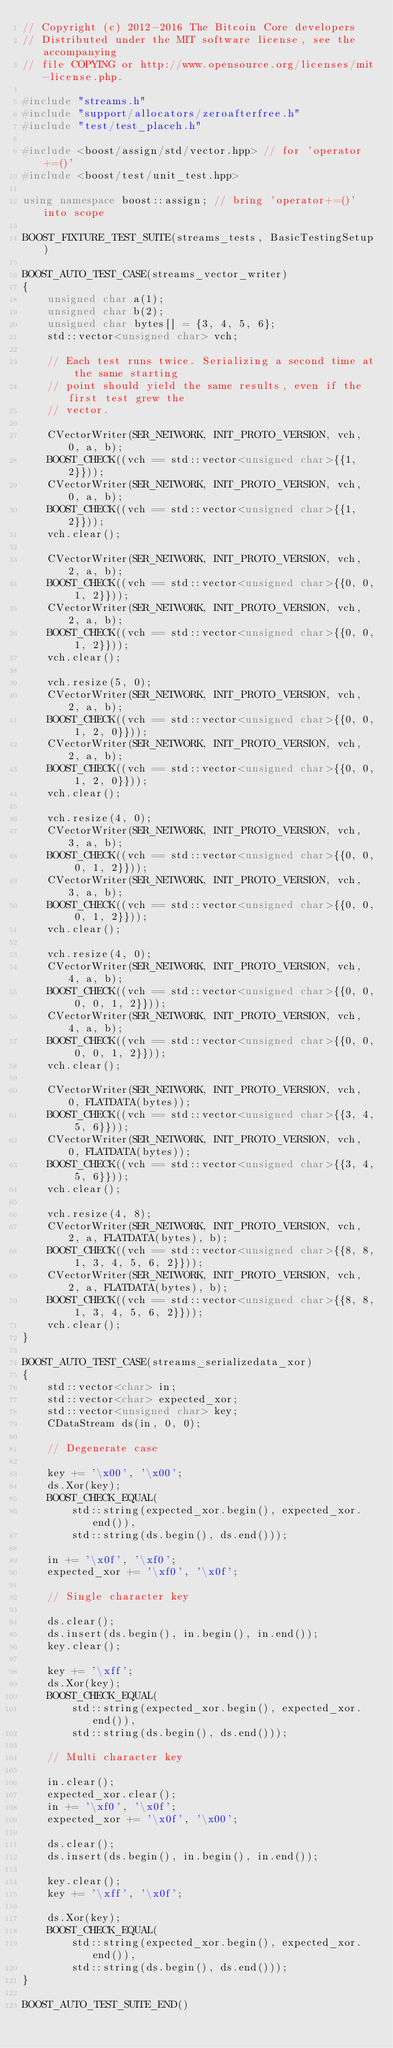<code> <loc_0><loc_0><loc_500><loc_500><_C++_>// Copyright (c) 2012-2016 The Bitcoin Core developers
// Distributed under the MIT software license, see the accompanying
// file COPYING or http://www.opensource.org/licenses/mit-license.php.

#include "streams.h"
#include "support/allocators/zeroafterfree.h"
#include "test/test_placeh.h"

#include <boost/assign/std/vector.hpp> // for 'operator+=()'
#include <boost/test/unit_test.hpp>

using namespace boost::assign; // bring 'operator+=()' into scope

BOOST_FIXTURE_TEST_SUITE(streams_tests, BasicTestingSetup)

BOOST_AUTO_TEST_CASE(streams_vector_writer)
{
    unsigned char a(1);
    unsigned char b(2);
    unsigned char bytes[] = {3, 4, 5, 6};
    std::vector<unsigned char> vch;

    // Each test runs twice. Serializing a second time at the same starting
    // point should yield the same results, even if the first test grew the
    // vector.

    CVectorWriter(SER_NETWORK, INIT_PROTO_VERSION, vch, 0, a, b);
    BOOST_CHECK((vch == std::vector<unsigned char>{{1, 2}}));
    CVectorWriter(SER_NETWORK, INIT_PROTO_VERSION, vch, 0, a, b);
    BOOST_CHECK((vch == std::vector<unsigned char>{{1, 2}}));
    vch.clear();

    CVectorWriter(SER_NETWORK, INIT_PROTO_VERSION, vch, 2, a, b);
    BOOST_CHECK((vch == std::vector<unsigned char>{{0, 0, 1, 2}}));
    CVectorWriter(SER_NETWORK, INIT_PROTO_VERSION, vch, 2, a, b);
    BOOST_CHECK((vch == std::vector<unsigned char>{{0, 0, 1, 2}}));
    vch.clear();

    vch.resize(5, 0);
    CVectorWriter(SER_NETWORK, INIT_PROTO_VERSION, vch, 2, a, b);
    BOOST_CHECK((vch == std::vector<unsigned char>{{0, 0, 1, 2, 0}}));
    CVectorWriter(SER_NETWORK, INIT_PROTO_VERSION, vch, 2, a, b);
    BOOST_CHECK((vch == std::vector<unsigned char>{{0, 0, 1, 2, 0}}));
    vch.clear();

    vch.resize(4, 0);
    CVectorWriter(SER_NETWORK, INIT_PROTO_VERSION, vch, 3, a, b);
    BOOST_CHECK((vch == std::vector<unsigned char>{{0, 0, 0, 1, 2}}));
    CVectorWriter(SER_NETWORK, INIT_PROTO_VERSION, vch, 3, a, b);
    BOOST_CHECK((vch == std::vector<unsigned char>{{0, 0, 0, 1, 2}}));
    vch.clear();

    vch.resize(4, 0);
    CVectorWriter(SER_NETWORK, INIT_PROTO_VERSION, vch, 4, a, b);
    BOOST_CHECK((vch == std::vector<unsigned char>{{0, 0, 0, 0, 1, 2}}));
    CVectorWriter(SER_NETWORK, INIT_PROTO_VERSION, vch, 4, a, b);
    BOOST_CHECK((vch == std::vector<unsigned char>{{0, 0, 0, 0, 1, 2}}));
    vch.clear();

    CVectorWriter(SER_NETWORK, INIT_PROTO_VERSION, vch, 0, FLATDATA(bytes));
    BOOST_CHECK((vch == std::vector<unsigned char>{{3, 4, 5, 6}}));
    CVectorWriter(SER_NETWORK, INIT_PROTO_VERSION, vch, 0, FLATDATA(bytes));
    BOOST_CHECK((vch == std::vector<unsigned char>{{3, 4, 5, 6}}));
    vch.clear();

    vch.resize(4, 8);
    CVectorWriter(SER_NETWORK, INIT_PROTO_VERSION, vch, 2, a, FLATDATA(bytes), b);
    BOOST_CHECK((vch == std::vector<unsigned char>{{8, 8, 1, 3, 4, 5, 6, 2}}));
    CVectorWriter(SER_NETWORK, INIT_PROTO_VERSION, vch, 2, a, FLATDATA(bytes), b);
    BOOST_CHECK((vch == std::vector<unsigned char>{{8, 8, 1, 3, 4, 5, 6, 2}}));
    vch.clear();
}

BOOST_AUTO_TEST_CASE(streams_serializedata_xor)
{
    std::vector<char> in;
    std::vector<char> expected_xor;
    std::vector<unsigned char> key;
    CDataStream ds(in, 0, 0);

    // Degenerate case

    key += '\x00', '\x00';
    ds.Xor(key);
    BOOST_CHECK_EQUAL(
        std::string(expected_xor.begin(), expected_xor.end()),
        std::string(ds.begin(), ds.end()));

    in += '\x0f', '\xf0';
    expected_xor += '\xf0', '\x0f';

    // Single character key

    ds.clear();
    ds.insert(ds.begin(), in.begin(), in.end());
    key.clear();

    key += '\xff';
    ds.Xor(key);
    BOOST_CHECK_EQUAL(
        std::string(expected_xor.begin(), expected_xor.end()),
        std::string(ds.begin(), ds.end()));

    // Multi character key

    in.clear();
    expected_xor.clear();
    in += '\xf0', '\x0f';
    expected_xor += '\x0f', '\x00';

    ds.clear();
    ds.insert(ds.begin(), in.begin(), in.end());

    key.clear();
    key += '\xff', '\x0f';

    ds.Xor(key);
    BOOST_CHECK_EQUAL(
        std::string(expected_xor.begin(), expected_xor.end()),
        std::string(ds.begin(), ds.end()));
}

BOOST_AUTO_TEST_SUITE_END()
</code> 